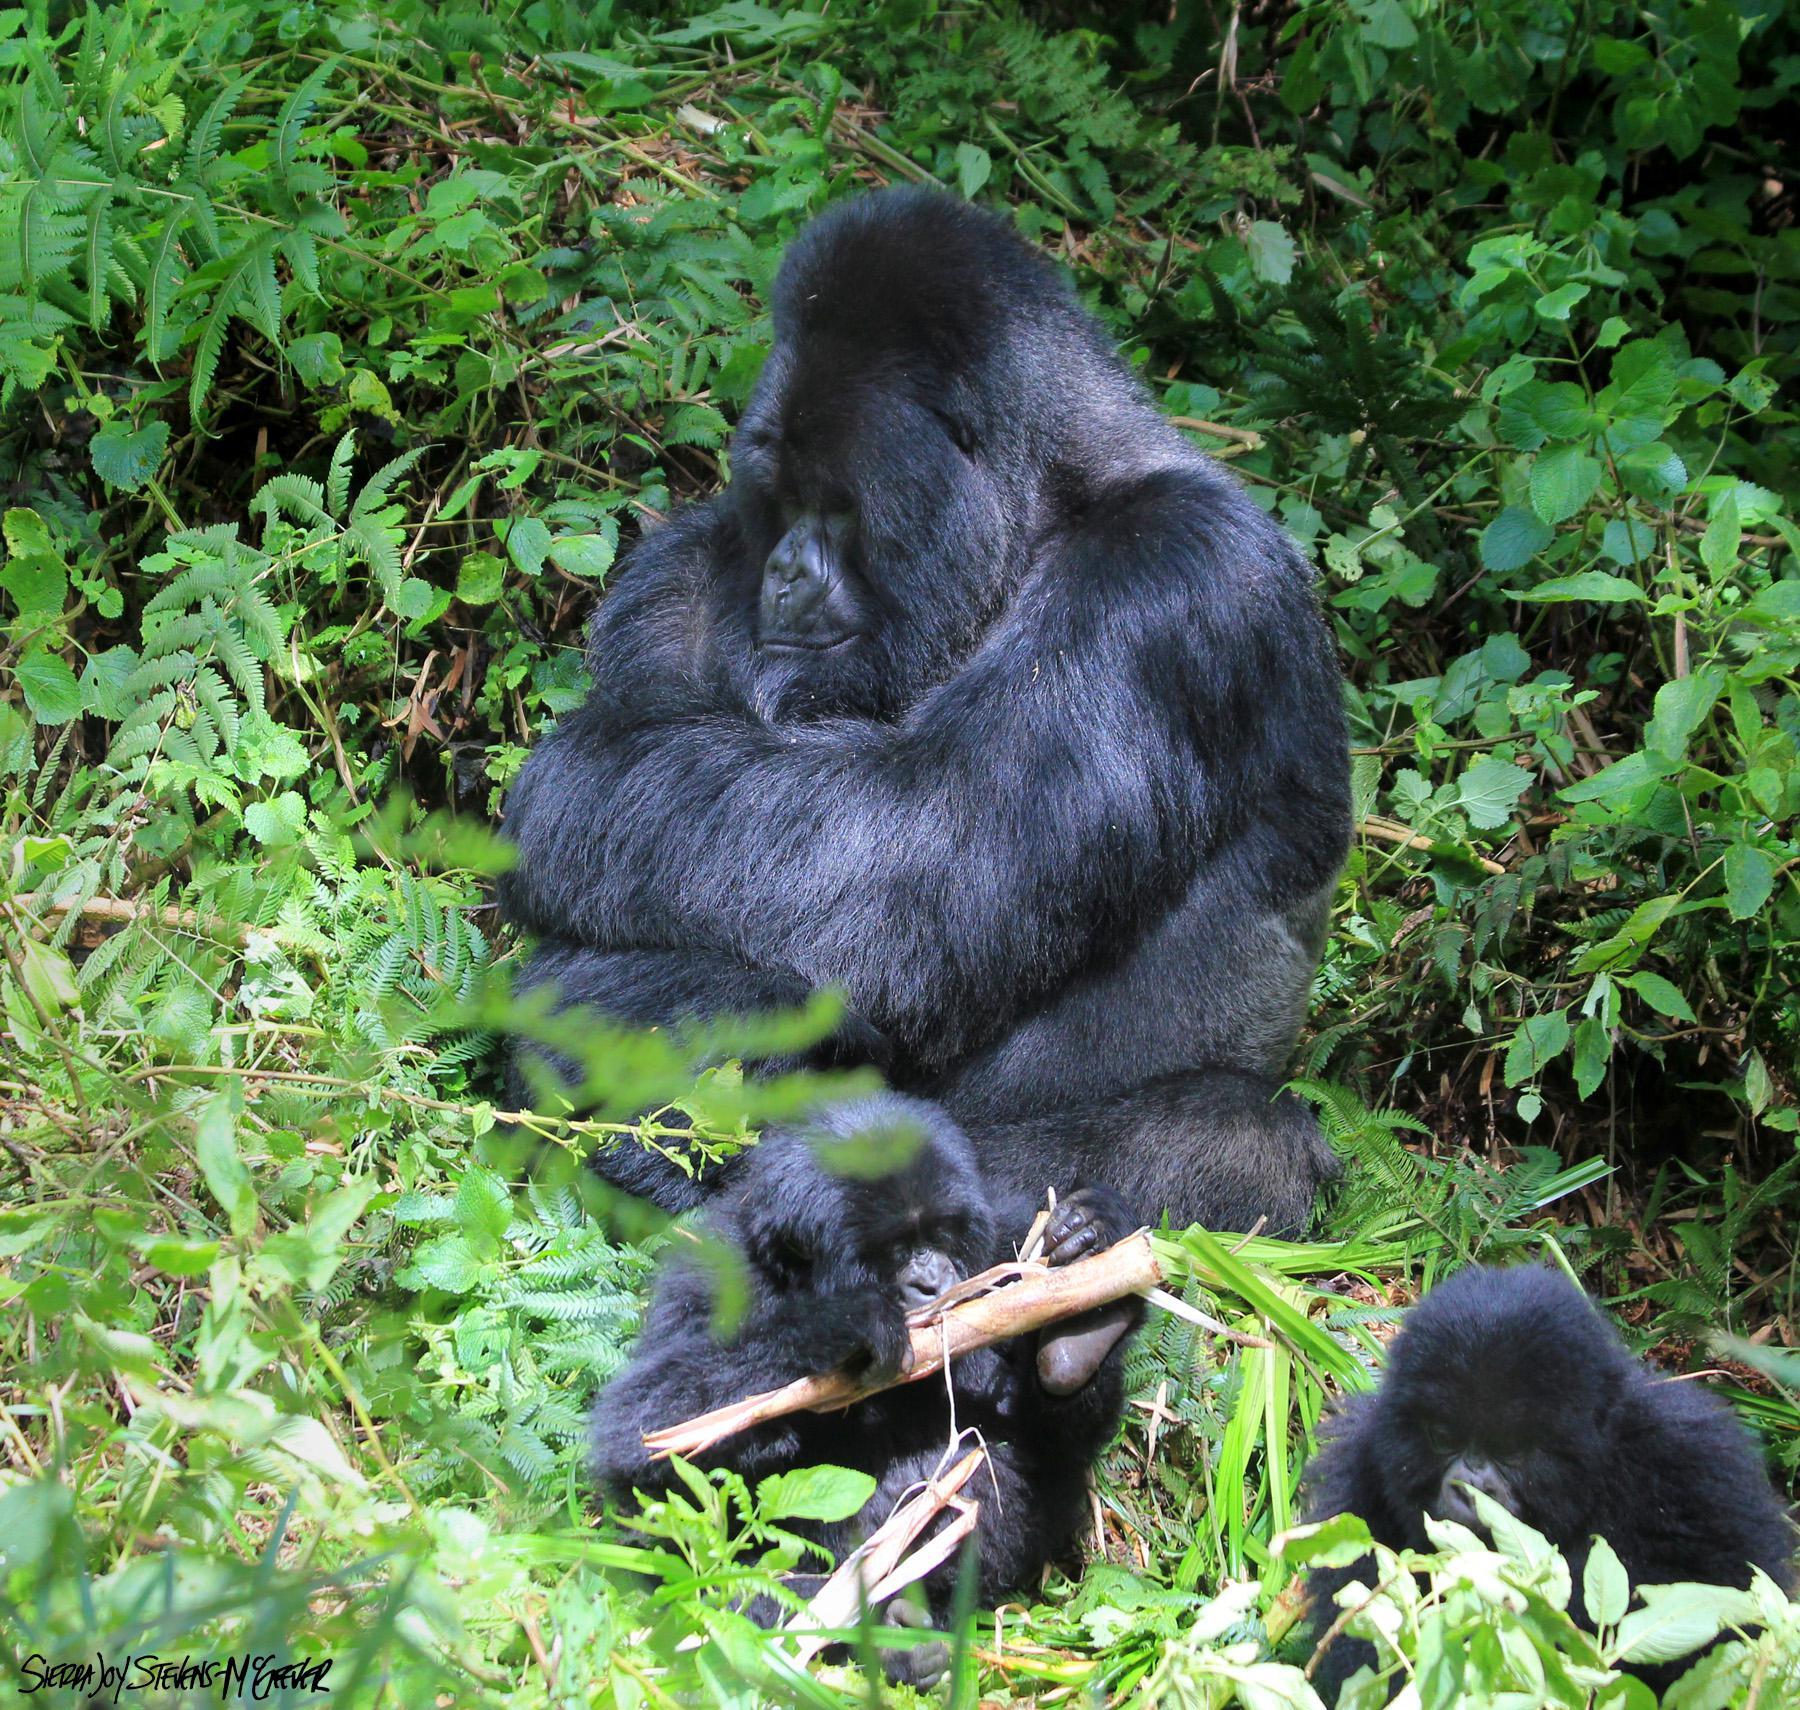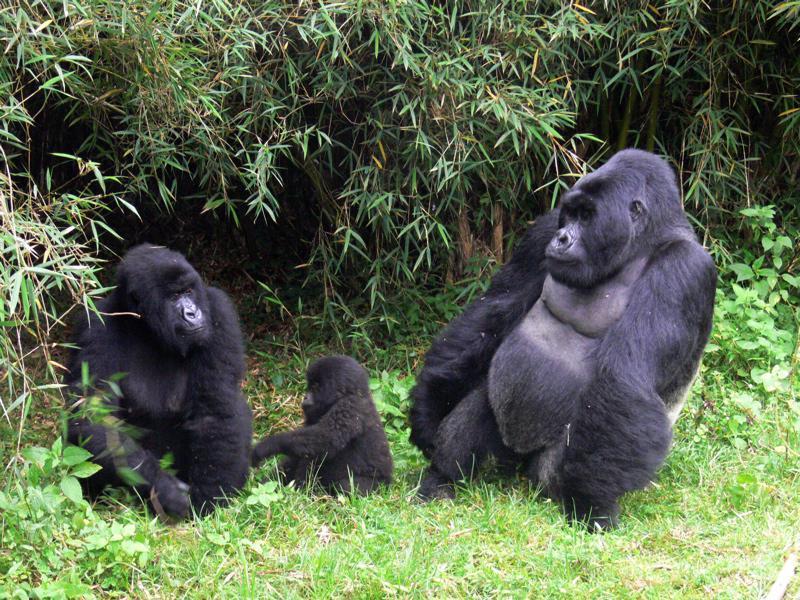The first image is the image on the left, the second image is the image on the right. Examine the images to the left and right. Is the description "There are no more than three gorillas" accurate? Answer yes or no. No. The first image is the image on the left, the second image is the image on the right. Analyze the images presented: Is the assertion "At least one images contains a very young gorilla." valid? Answer yes or no. Yes. 